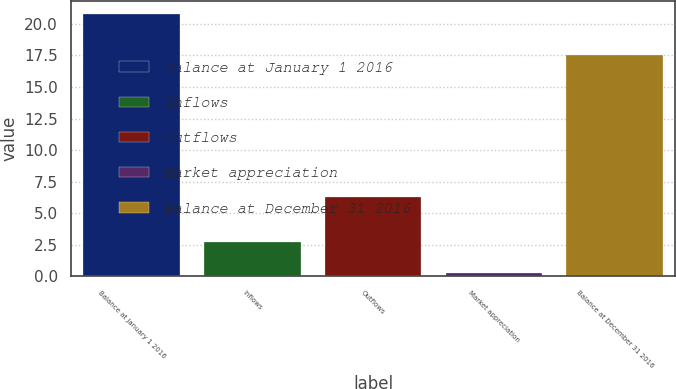Convert chart. <chart><loc_0><loc_0><loc_500><loc_500><bar_chart><fcel>Balance at January 1 2016<fcel>Inflows<fcel>Outflows<fcel>Market appreciation<fcel>Balance at December 31 2016<nl><fcel>20.8<fcel>2.7<fcel>6.3<fcel>0.3<fcel>17.5<nl></chart> 